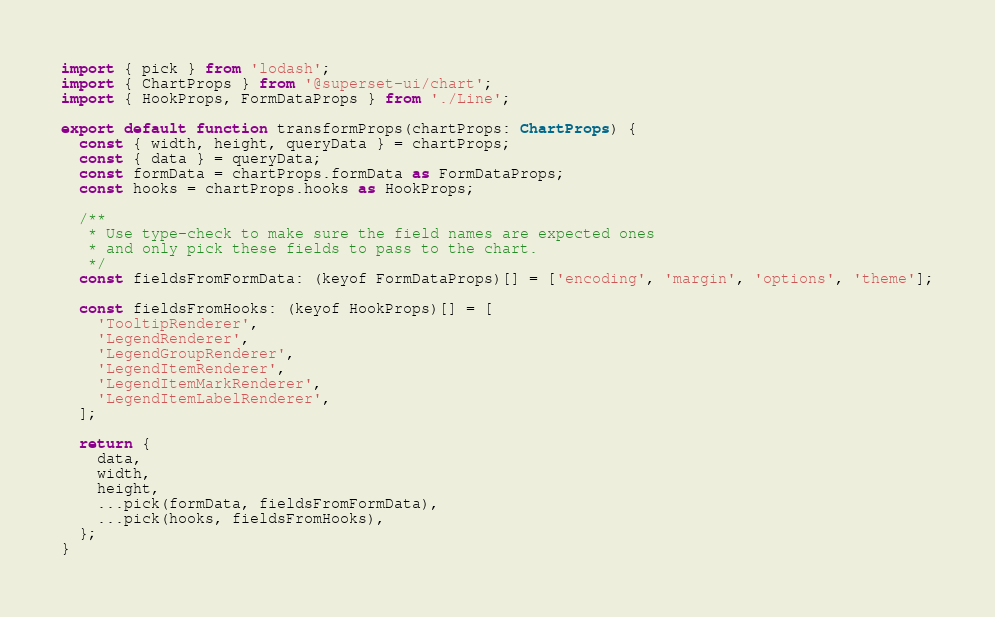Convert code to text. <code><loc_0><loc_0><loc_500><loc_500><_TypeScript_>import { pick } from 'lodash';
import { ChartProps } from '@superset-ui/chart';
import { HookProps, FormDataProps } from './Line';

export default function transformProps(chartProps: ChartProps) {
  const { width, height, queryData } = chartProps;
  const { data } = queryData;
  const formData = chartProps.formData as FormDataProps;
  const hooks = chartProps.hooks as HookProps;

  /**
   * Use type-check to make sure the field names are expected ones
   * and only pick these fields to pass to the chart.
   */
  const fieldsFromFormData: (keyof FormDataProps)[] = ['encoding', 'margin', 'options', 'theme'];

  const fieldsFromHooks: (keyof HookProps)[] = [
    'TooltipRenderer',
    'LegendRenderer',
    'LegendGroupRenderer',
    'LegendItemRenderer',
    'LegendItemMarkRenderer',
    'LegendItemLabelRenderer',
  ];

  return {
    data,
    width,
    height,
    ...pick(formData, fieldsFromFormData),
    ...pick(hooks, fieldsFromHooks),
  };
}
</code> 